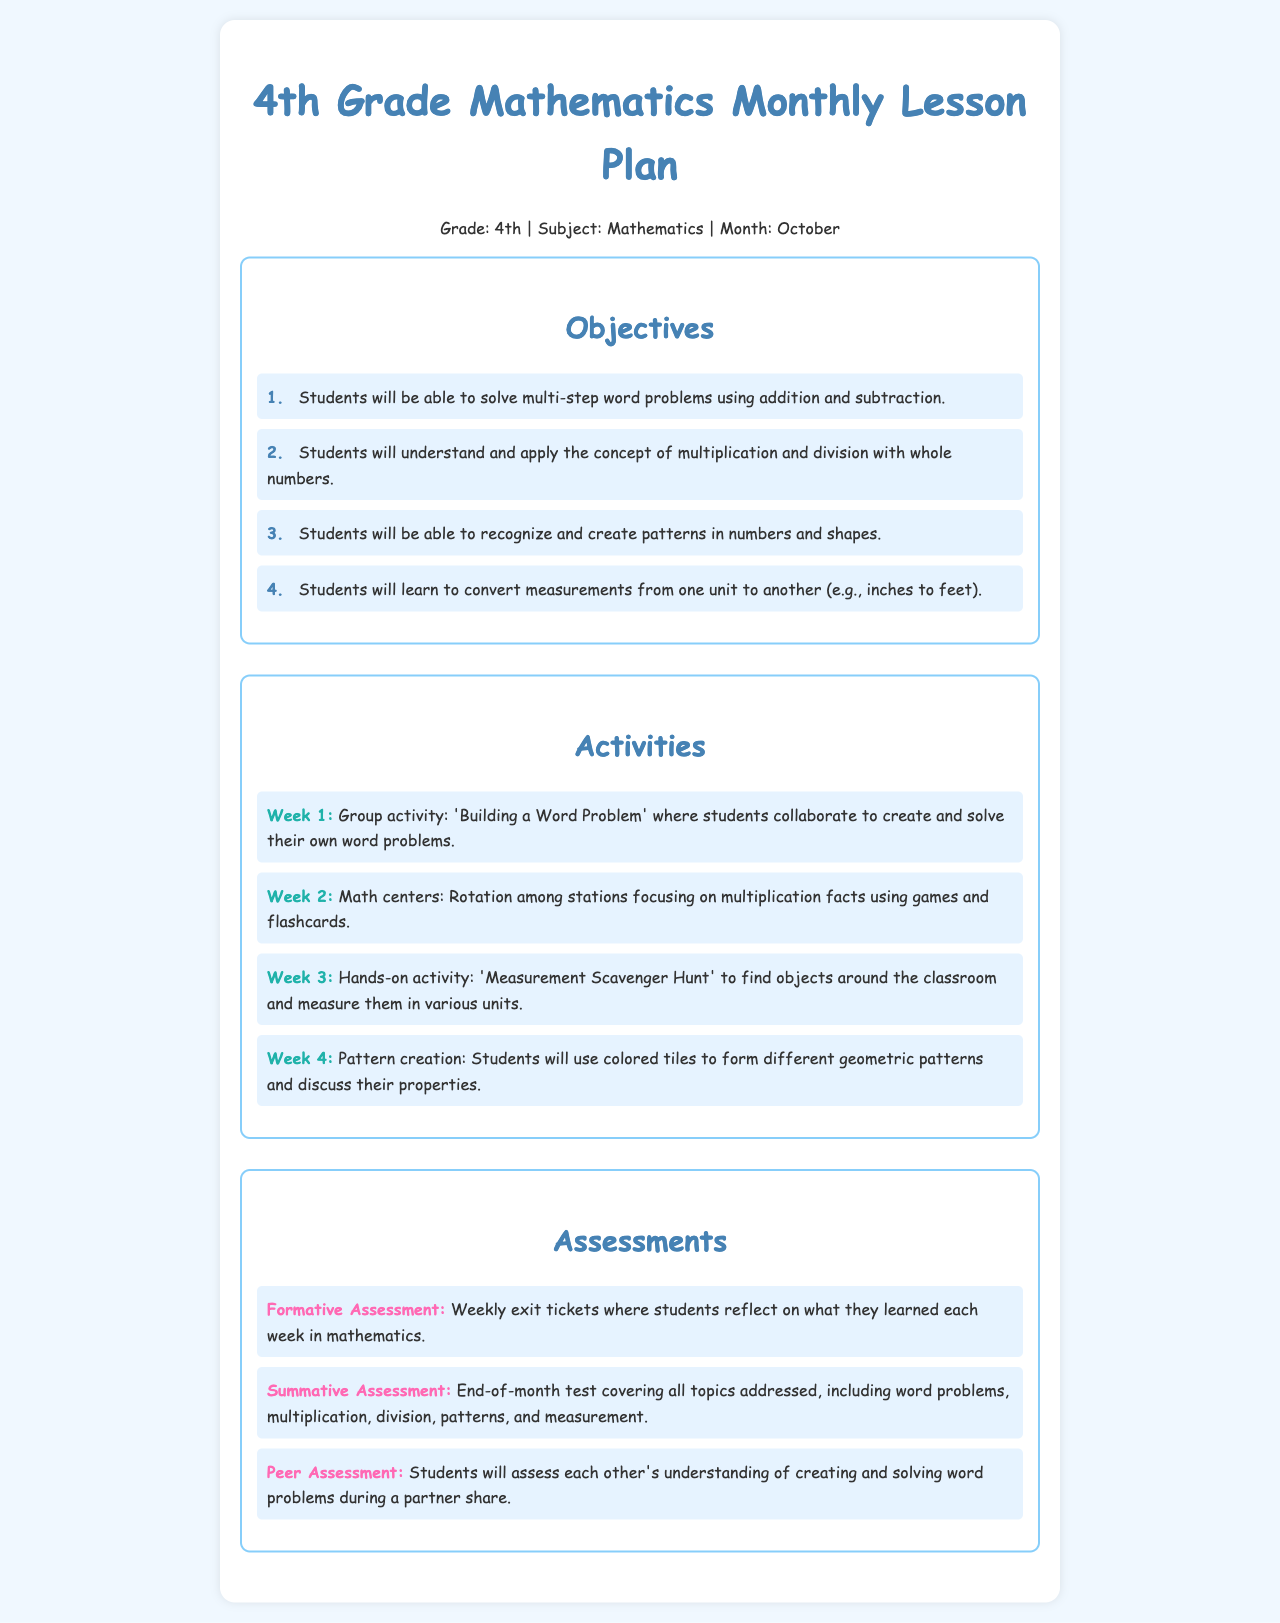what is the title of the document? The title is stated at the top of the document as "4th Grade Mathematics Monthly Lesson Plan."
Answer: 4th Grade Mathematics Monthly Lesson Plan what month is this lesson plan for? The document specifies that the lesson plan is for the month of October.
Answer: October how many objectives are listed in the document? The document enumerates a total of four objectives.
Answer: 4 which week features a 'Measurement Scavenger Hunt'? The 'Measurement Scavenger Hunt' is mentioned as the activity for Week 3.
Answer: Week 3 what type of assessment is described as "Weekly exit tickets"? "Weekly exit tickets" refer to a formative assessment mentioned in the assessment section.
Answer: Formative Assessment which activity involves creating geometric patterns? The activity that involves creating geometric patterns is described in Week 4 of the activities section.
Answer: Week 4 what is the focus of the second week's activities? The second week's activities focus on multiplication facts using games and flashcards.
Answer: Multiplication facts what type of assessment is conducted at the end of the month? The end-of-month test described covers all topics and is categorized as a summative assessment.
Answer: Summative Assessment 